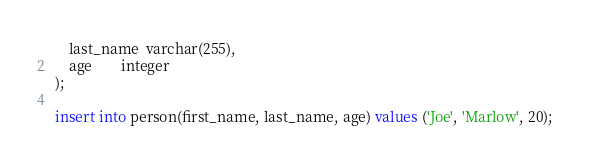Convert code to text. <code><loc_0><loc_0><loc_500><loc_500><_SQL_>    last_name  varchar(255),
    age        integer
);

insert into person(first_name, last_name, age) values ('Joe', 'Marlow', 20);
</code> 